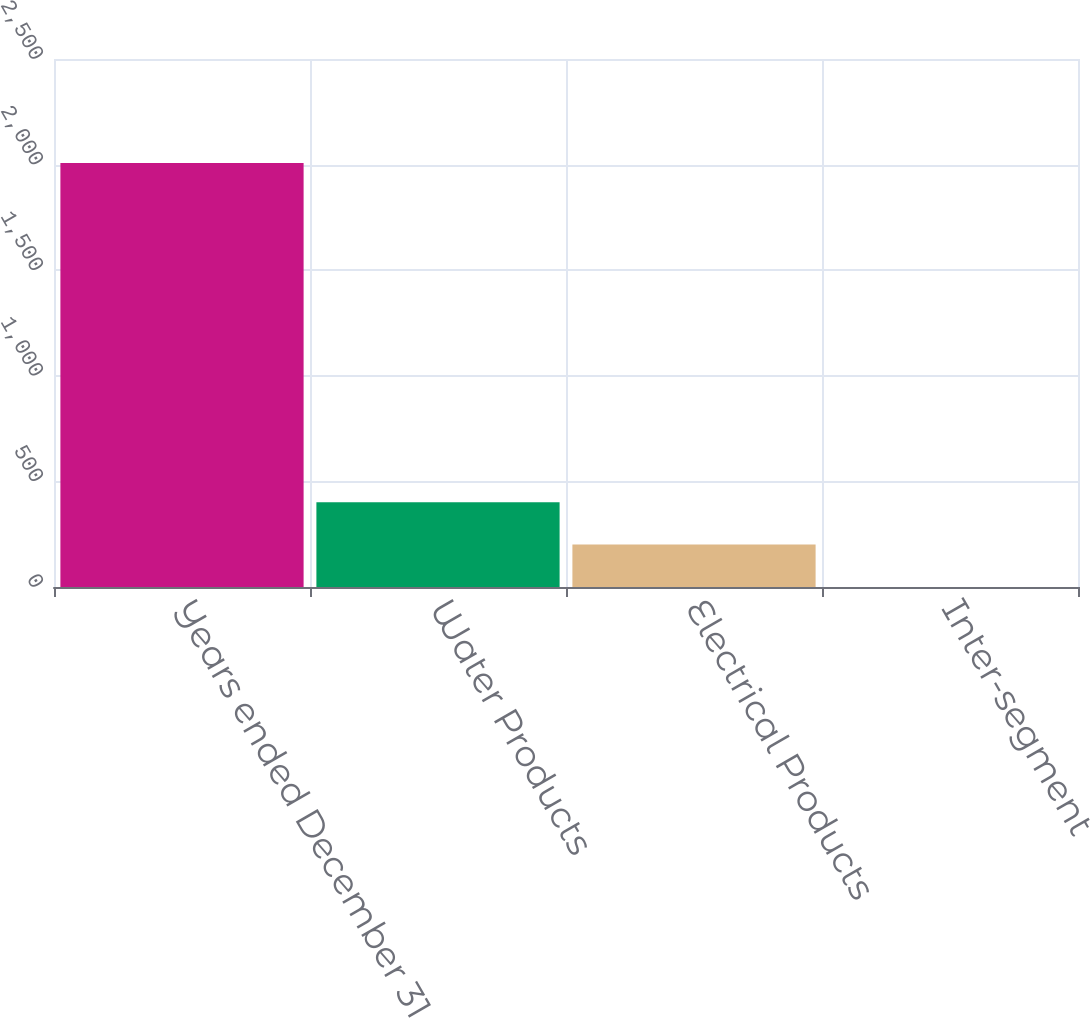<chart> <loc_0><loc_0><loc_500><loc_500><bar_chart><fcel>Years ended December 31<fcel>Water Products<fcel>Electrical Products<fcel>Inter-segment<nl><fcel>2007<fcel>401.56<fcel>200.88<fcel>0.2<nl></chart> 